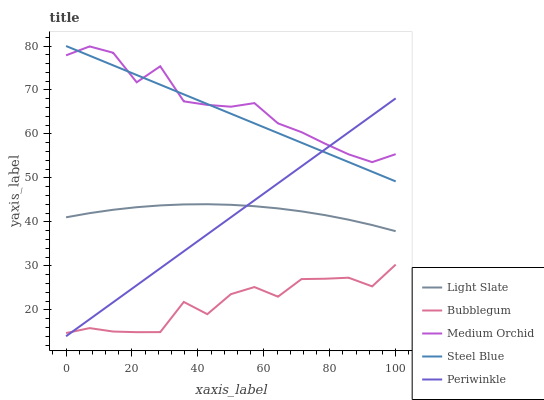Does Bubblegum have the minimum area under the curve?
Answer yes or no. Yes. Does Medium Orchid have the maximum area under the curve?
Answer yes or no. Yes. Does Periwinkle have the minimum area under the curve?
Answer yes or no. No. Does Periwinkle have the maximum area under the curve?
Answer yes or no. No. Is Periwinkle the smoothest?
Answer yes or no. Yes. Is Bubblegum the roughest?
Answer yes or no. Yes. Is Medium Orchid the smoothest?
Answer yes or no. No. Is Medium Orchid the roughest?
Answer yes or no. No. Does Medium Orchid have the lowest value?
Answer yes or no. No. Does Steel Blue have the highest value?
Answer yes or no. Yes. Does Medium Orchid have the highest value?
Answer yes or no. No. Is Bubblegum less than Light Slate?
Answer yes or no. Yes. Is Light Slate greater than Bubblegum?
Answer yes or no. Yes. Does Periwinkle intersect Steel Blue?
Answer yes or no. Yes. Is Periwinkle less than Steel Blue?
Answer yes or no. No. Is Periwinkle greater than Steel Blue?
Answer yes or no. No. Does Bubblegum intersect Light Slate?
Answer yes or no. No. 